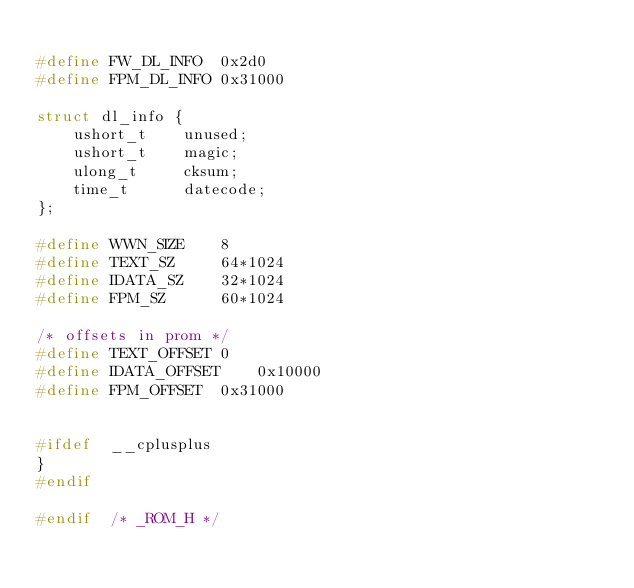Convert code to text. <code><loc_0><loc_0><loc_500><loc_500><_C_>
#define	FW_DL_INFO	0x2d0
#define	FPM_DL_INFO	0x31000

struct dl_info {
	ushort_t	unused;
	ushort_t	magic;
	ulong_t		cksum;
	time_t		datecode;
};

#define	WWN_SIZE	8
#define	TEXT_SZ		64*1024
#define	IDATA_SZ	32*1024
#define	FPM_SZ		60*1024

/* offsets in prom */
#define	TEXT_OFFSET	0
#define	IDATA_OFFSET	0x10000
#define	FPM_OFFSET	0x31000


#ifdef	__cplusplus
}
#endif

#endif	/* _ROM_H */
</code> 